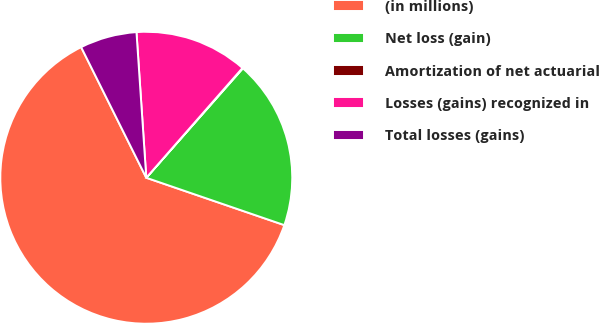Convert chart. <chart><loc_0><loc_0><loc_500><loc_500><pie_chart><fcel>(in millions)<fcel>Net loss (gain)<fcel>Amortization of net actuarial<fcel>Losses (gains) recognized in<fcel>Total losses (gains)<nl><fcel>62.37%<fcel>18.75%<fcel>0.06%<fcel>12.52%<fcel>6.29%<nl></chart> 